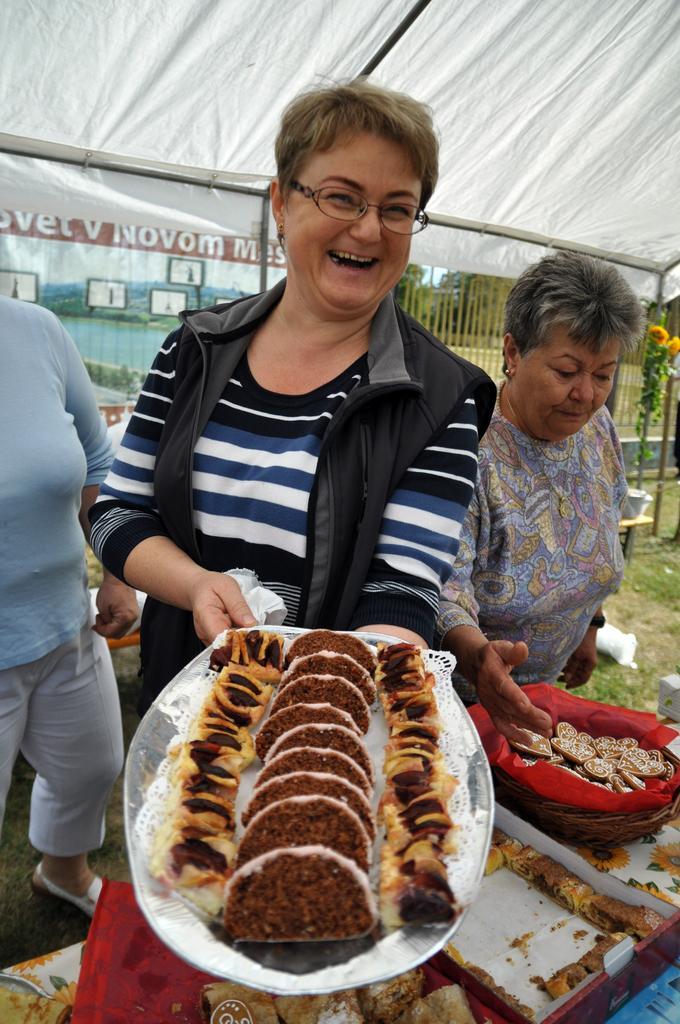Can you describe this image briefly? In the background we can see trees, grass, fence. We can see people under the tent. We can see a person wearing spectacles and holding a tray. We can see food items in a basket, box. 